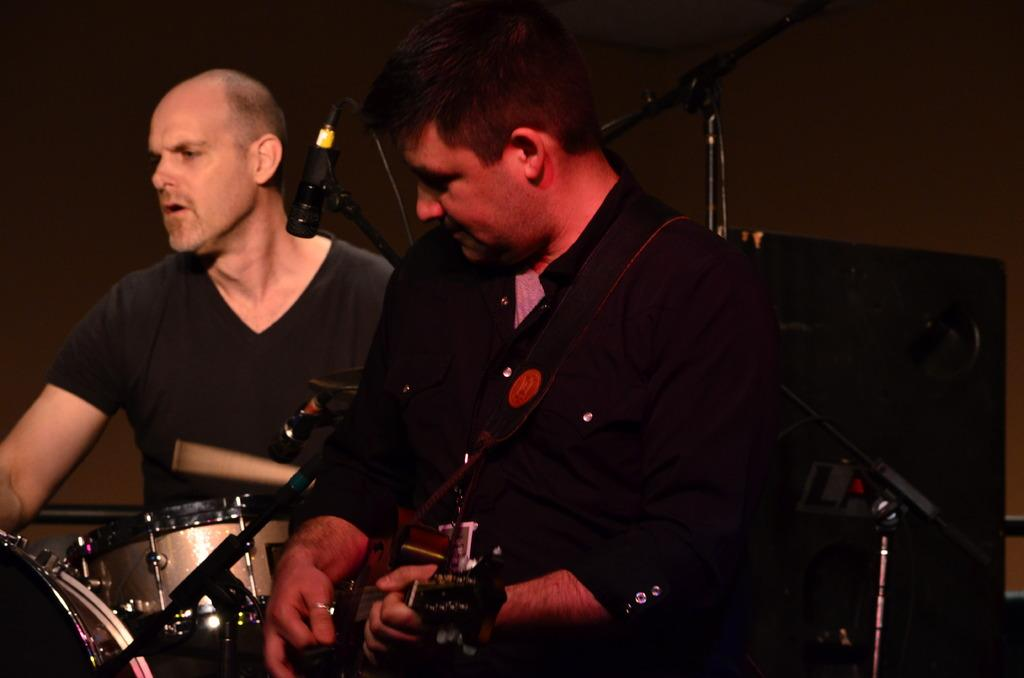What is the person on the left side of the image doing? The person on the left side of the image is holding a guitar. What is the person on the right side of the image doing? The person on the right side of the image is playing drums. What object is present for amplifying sound in the image? There is a speaker in the background of the image. What objects are present for holding microphones in the image? There are mic stands in the image. What type of vegetable is being washed in the image? There is no vegetable or washing activity present in the image. 